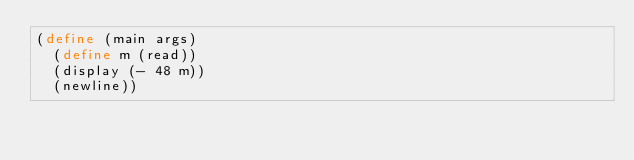<code> <loc_0><loc_0><loc_500><loc_500><_Scheme_>(define (main args)
  (define m (read))
  (display (- 48 m))
  (newline))
</code> 